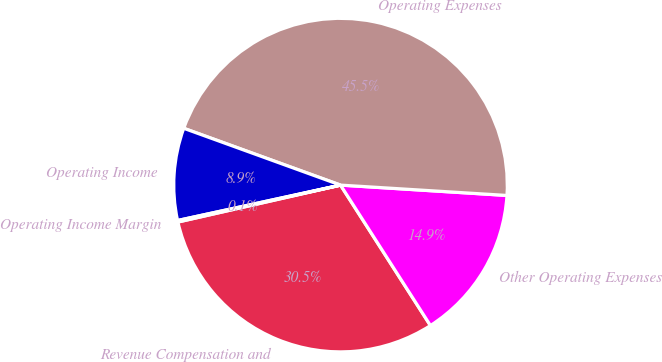Convert chart. <chart><loc_0><loc_0><loc_500><loc_500><pie_chart><fcel>Revenue Compensation and<fcel>Other Operating Expenses<fcel>Operating Expenses<fcel>Operating Income<fcel>Operating Income Margin<nl><fcel>30.51%<fcel>14.95%<fcel>45.46%<fcel>8.94%<fcel>0.15%<nl></chart> 